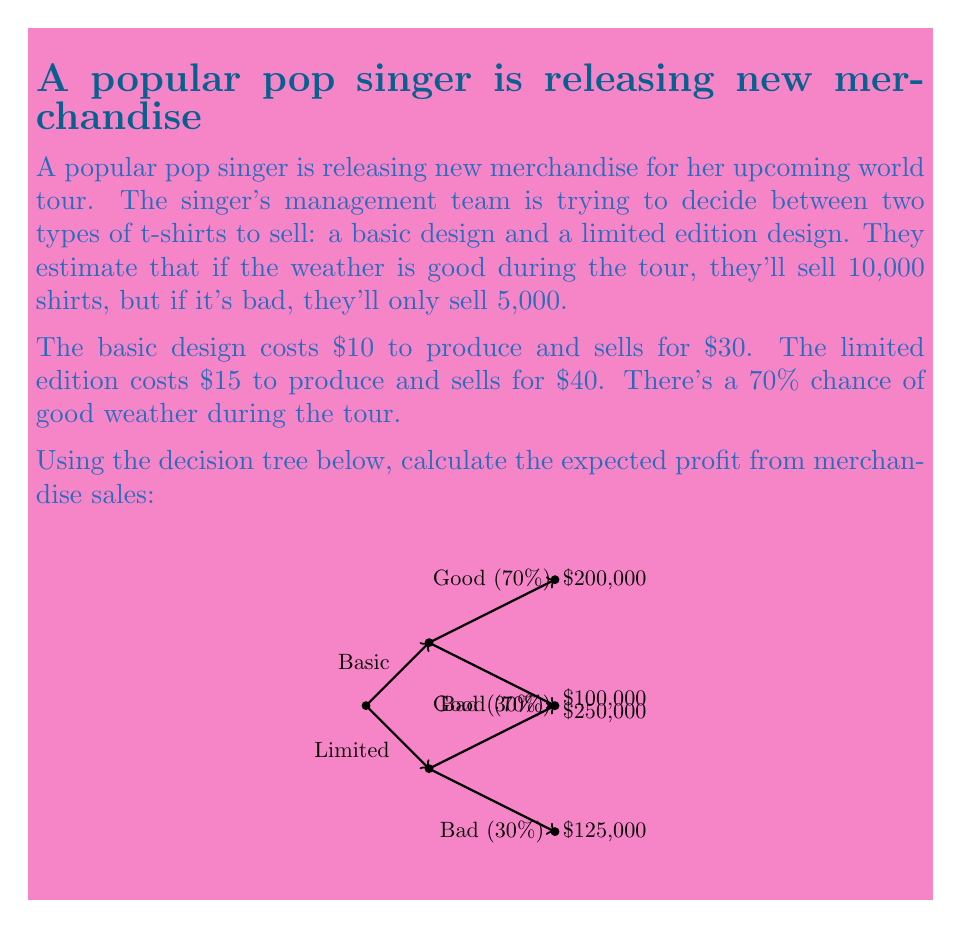Provide a solution to this math problem. Let's solve this problem step by step using the decision tree method:

1) First, let's calculate the expected value for each option:

   For the Basic design:
   $$EV_{Basic} = 0.7 \times \$200,000 + 0.3 \times \$100,000$$
   $$EV_{Basic} = \$140,000 + \$30,000 = \$170,000$$

   For the Limited edition:
   $$EV_{Limited} = 0.7 \times \$250,000 + 0.3 \times \$125,000$$
   $$EV_{Limited} = \$175,000 + \$37,500 = \$212,500$$

2) The decision rule is to choose the option with the highest expected value. In this case, the Limited edition design has a higher expected value.

3) Therefore, the expected profit is $212,500.

Note: We can verify these calculations:
   
   Basic design:
   Good weather: 10,000 × ($30 - $10) = $200,000
   Bad weather: 5,000 × ($30 - $10) = $100,000

   Limited edition:
   Good weather: 10,000 × ($40 - $15) = $250,000
   Bad weather: 5,000 × ($40 - $15) = $125,000

These match the values given in the decision tree.
Answer: $212,500 